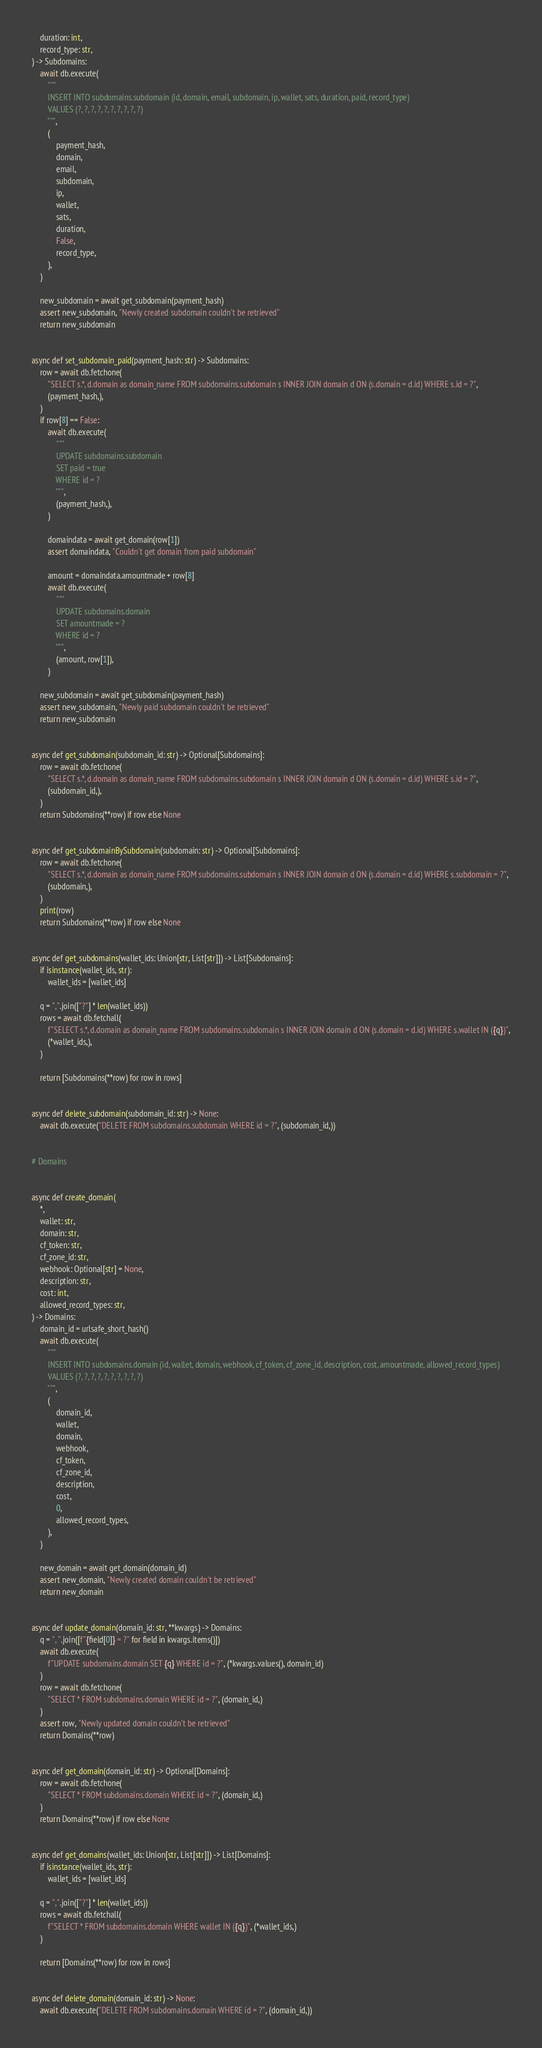Convert code to text. <code><loc_0><loc_0><loc_500><loc_500><_Python_>    duration: int,
    record_type: str,
) -> Subdomains:
    await db.execute(
        """
        INSERT INTO subdomains.subdomain (id, domain, email, subdomain, ip, wallet, sats, duration, paid, record_type)
        VALUES (?, ?, ?, ?, ?, ?, ?, ?, ?, ?)
        """,
        (
            payment_hash,
            domain,
            email,
            subdomain,
            ip,
            wallet,
            sats,
            duration,
            False,
            record_type,
        ),
    )

    new_subdomain = await get_subdomain(payment_hash)
    assert new_subdomain, "Newly created subdomain couldn't be retrieved"
    return new_subdomain


async def set_subdomain_paid(payment_hash: str) -> Subdomains:
    row = await db.fetchone(
        "SELECT s.*, d.domain as domain_name FROM subdomains.subdomain s INNER JOIN domain d ON (s.domain = d.id) WHERE s.id = ?",
        (payment_hash,),
    )
    if row[8] == False:
        await db.execute(
            """
            UPDATE subdomains.subdomain
            SET paid = true
            WHERE id = ?
            """,
            (payment_hash,),
        )

        domaindata = await get_domain(row[1])
        assert domaindata, "Couldn't get domain from paid subdomain"

        amount = domaindata.amountmade + row[8]
        await db.execute(
            """
            UPDATE subdomains.domain
            SET amountmade = ?
            WHERE id = ?
            """,
            (amount, row[1]),
        )

    new_subdomain = await get_subdomain(payment_hash)
    assert new_subdomain, "Newly paid subdomain couldn't be retrieved"
    return new_subdomain


async def get_subdomain(subdomain_id: str) -> Optional[Subdomains]:
    row = await db.fetchone(
        "SELECT s.*, d.domain as domain_name FROM subdomains.subdomain s INNER JOIN domain d ON (s.domain = d.id) WHERE s.id = ?",
        (subdomain_id,),
    )
    return Subdomains(**row) if row else None


async def get_subdomainBySubdomain(subdomain: str) -> Optional[Subdomains]:
    row = await db.fetchone(
        "SELECT s.*, d.domain as domain_name FROM subdomains.subdomain s INNER JOIN domain d ON (s.domain = d.id) WHERE s.subdomain = ?",
        (subdomain,),
    )
    print(row)
    return Subdomains(**row) if row else None


async def get_subdomains(wallet_ids: Union[str, List[str]]) -> List[Subdomains]:
    if isinstance(wallet_ids, str):
        wallet_ids = [wallet_ids]

    q = ",".join(["?"] * len(wallet_ids))
    rows = await db.fetchall(
        f"SELECT s.*, d.domain as domain_name FROM subdomains.subdomain s INNER JOIN domain d ON (s.domain = d.id) WHERE s.wallet IN ({q})",
        (*wallet_ids,),
    )

    return [Subdomains(**row) for row in rows]


async def delete_subdomain(subdomain_id: str) -> None:
    await db.execute("DELETE FROM subdomains.subdomain WHERE id = ?", (subdomain_id,))


# Domains


async def create_domain(
    *,
    wallet: str,
    domain: str,
    cf_token: str,
    cf_zone_id: str,
    webhook: Optional[str] = None,
    description: str,
    cost: int,
    allowed_record_types: str,
) -> Domains:
    domain_id = urlsafe_short_hash()
    await db.execute(
        """
        INSERT INTO subdomains.domain (id, wallet, domain, webhook, cf_token, cf_zone_id, description, cost, amountmade, allowed_record_types)
        VALUES (?, ?, ?, ?, ?, ?, ?, ?, ?, ?)
        """,
        (
            domain_id,
            wallet,
            domain,
            webhook,
            cf_token,
            cf_zone_id,
            description,
            cost,
            0,
            allowed_record_types,
        ),
    )

    new_domain = await get_domain(domain_id)
    assert new_domain, "Newly created domain couldn't be retrieved"
    return new_domain


async def update_domain(domain_id: str, **kwargs) -> Domains:
    q = ", ".join([f"{field[0]} = ?" for field in kwargs.items()])
    await db.execute(
        f"UPDATE subdomains.domain SET {q} WHERE id = ?", (*kwargs.values(), domain_id)
    )
    row = await db.fetchone(
        "SELECT * FROM subdomains.domain WHERE id = ?", (domain_id,)
    )
    assert row, "Newly updated domain couldn't be retrieved"
    return Domains(**row)


async def get_domain(domain_id: str) -> Optional[Domains]:
    row = await db.fetchone(
        "SELECT * FROM subdomains.domain WHERE id = ?", (domain_id,)
    )
    return Domains(**row) if row else None


async def get_domains(wallet_ids: Union[str, List[str]]) -> List[Domains]:
    if isinstance(wallet_ids, str):
        wallet_ids = [wallet_ids]

    q = ",".join(["?"] * len(wallet_ids))
    rows = await db.fetchall(
        f"SELECT * FROM subdomains.domain WHERE wallet IN ({q})", (*wallet_ids,)
    )

    return [Domains(**row) for row in rows]


async def delete_domain(domain_id: str) -> None:
    await db.execute("DELETE FROM subdomains.domain WHERE id = ?", (domain_id,))
</code> 